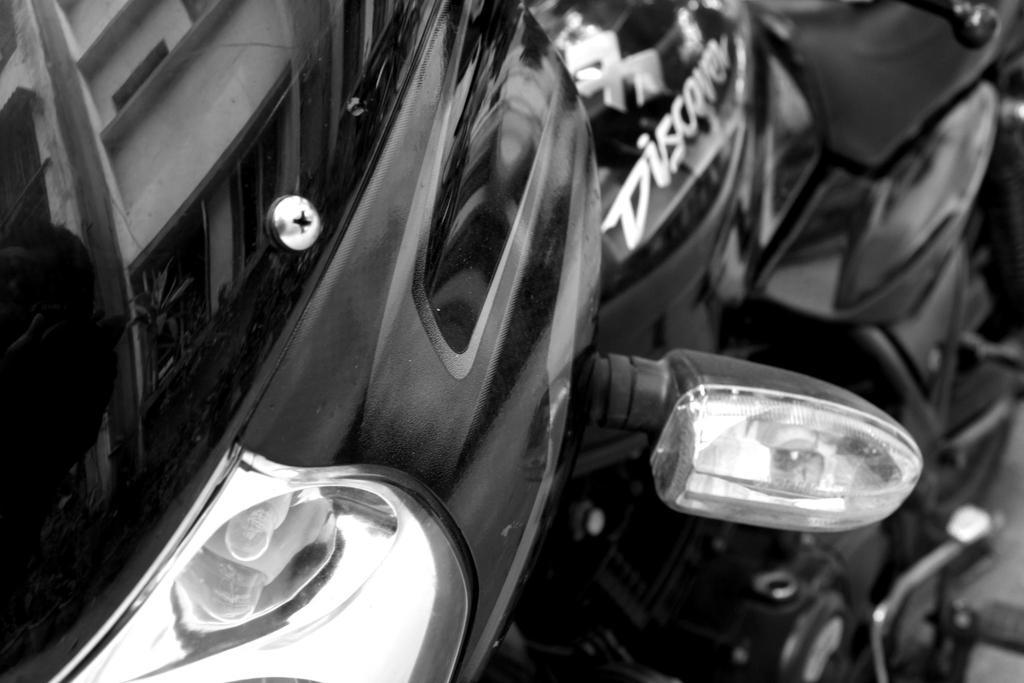What is the main subject in the foreground of the image? There is a motorbike in the foreground of the image. How many cows can be seen swimming in the ocean in the image? There are no cows or ocean present in the image; it features a motorbike in the foreground. 